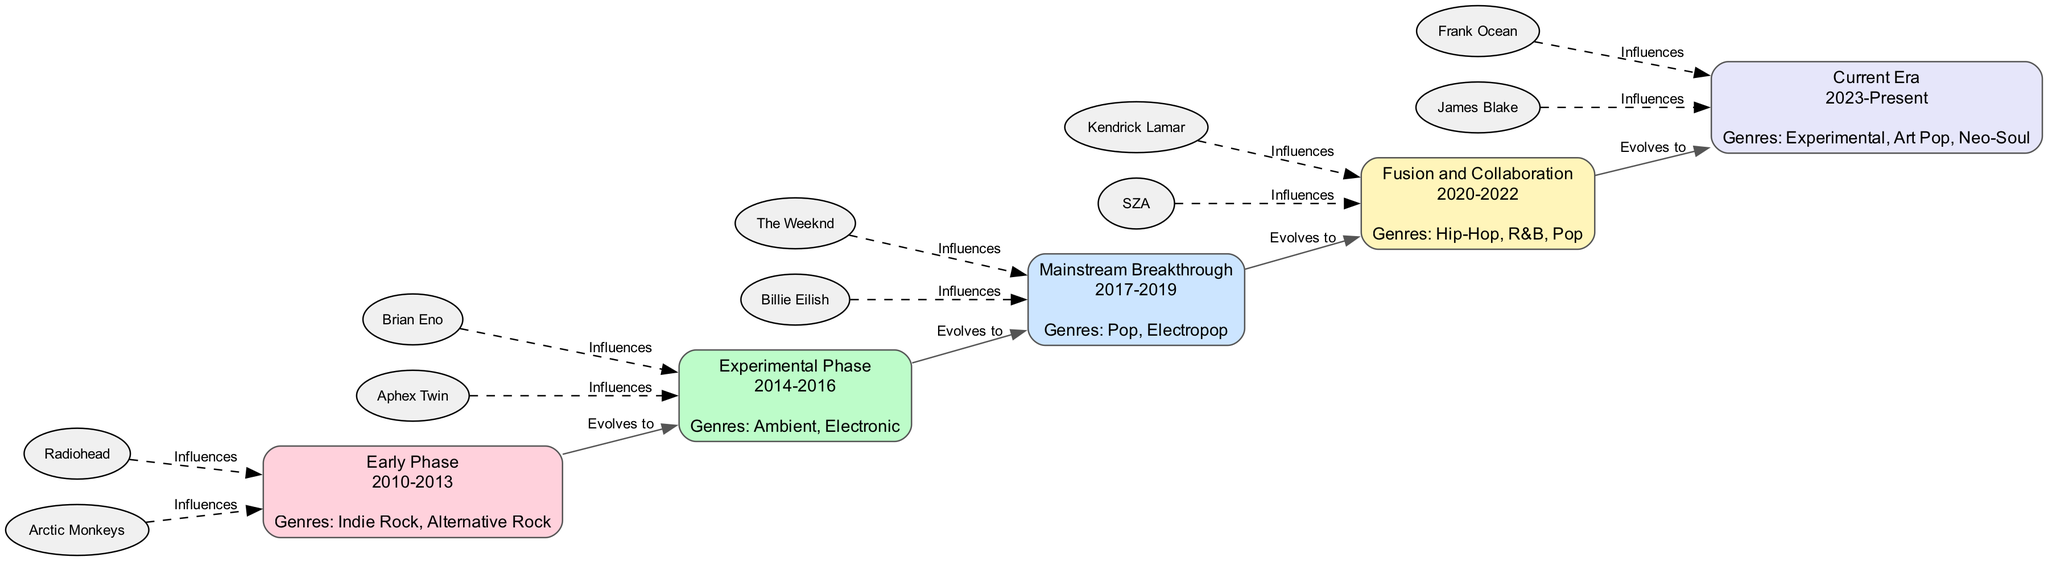What is the time period of the Early Phase? The Early Phase is labeled as occurring from 2010 to 2013 in the diagram. This information is directly indicated in the node description.
Answer: 2010-2013 How many phases are depicted in the diagram? The diagram contains five distinct phases, each represented by a node, which corresponds to the five elements provided in the data.
Answer: 5 Which genre was prominent during the Experimental Phase? The Experimental Phase node states that the prominent genres during this period are Ambient and Electronic, as explicitly listed under its description.
Answer: Ambient, Electronic What influences are associated with the Fusion and Collaboration phase? The Fusion and Collaboration phase lists Kendrick Lamar and SZA as influences, which are shown as separate nodes connected by dashed lines to the phase node.
Answer: Kendrick Lamar, SZA Which phase directly follows the Mainstream Breakthrough? The diagram indicates that the Fusion and Collaboration phase directly follows the Mainstream Breakthrough phase, as connected by a solid edge labeled 'Evolves to'.
Answer: Fusion and Collaboration What is the main genre observed in the Current Era? In the Current Era node, the genres listed include Experimental, Art Pop, and Neo-Soul. The question asks for the main genre, which is implied to mean the most contemporary style present.
Answer: Experimental How did Nazhan Zulkifle’s music style evolve from the Early Phase to the Current Era? The evolution progression can be determined by tracing the solid edges connecting each phase sequentially from the Early Phase to the Current Era, showing a transition through various styles and influences.
Answer: Various genre shifts and influences What are the influences from 2017-2019? The phase described as Mainstream Breakthrough lists The Weeknd and Billie Eilish as the influences relevant during the time period of 2017 to 2019.
Answer: The Weeknd, Billie Eilish Which two artists influenced Nazhan Zulkifle in the Current Era? The Current Era phase identifies Frank Ocean and James Blake as the prominent influences, which are clearly shown in the node.
Answer: Frank Ocean, James Blake 